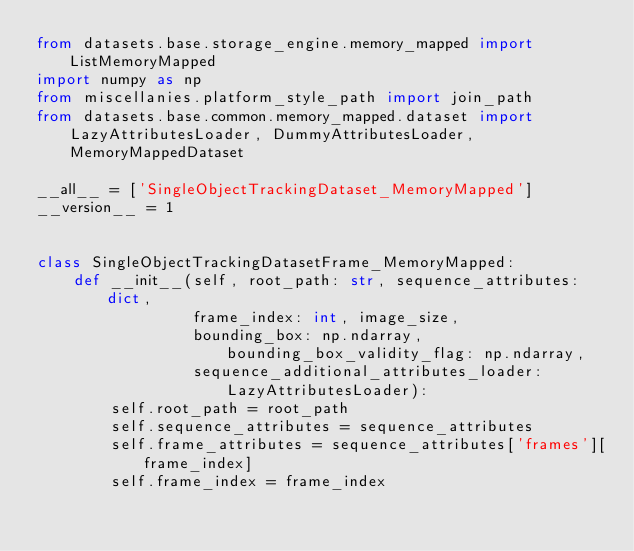<code> <loc_0><loc_0><loc_500><loc_500><_Python_>from datasets.base.storage_engine.memory_mapped import ListMemoryMapped
import numpy as np
from miscellanies.platform_style_path import join_path
from datasets.base.common.memory_mapped.dataset import LazyAttributesLoader, DummyAttributesLoader, MemoryMappedDataset

__all__ = ['SingleObjectTrackingDataset_MemoryMapped']
__version__ = 1


class SingleObjectTrackingDatasetFrame_MemoryMapped:
    def __init__(self, root_path: str, sequence_attributes: dict,
                 frame_index: int, image_size,
                 bounding_box: np.ndarray, bounding_box_validity_flag: np.ndarray,
                 sequence_additional_attributes_loader: LazyAttributesLoader):
        self.root_path = root_path
        self.sequence_attributes = sequence_attributes
        self.frame_attributes = sequence_attributes['frames'][frame_index]
        self.frame_index = frame_index</code> 